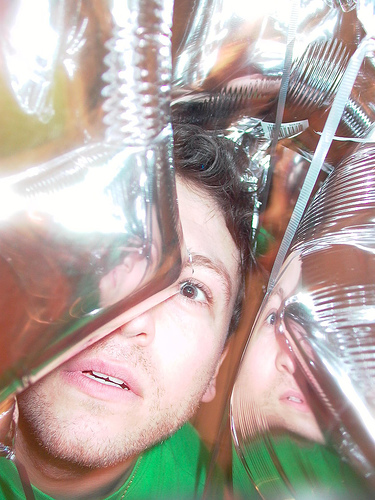<image>
Is the balloon in front of the man? Yes. The balloon is positioned in front of the man, appearing closer to the camera viewpoint. 